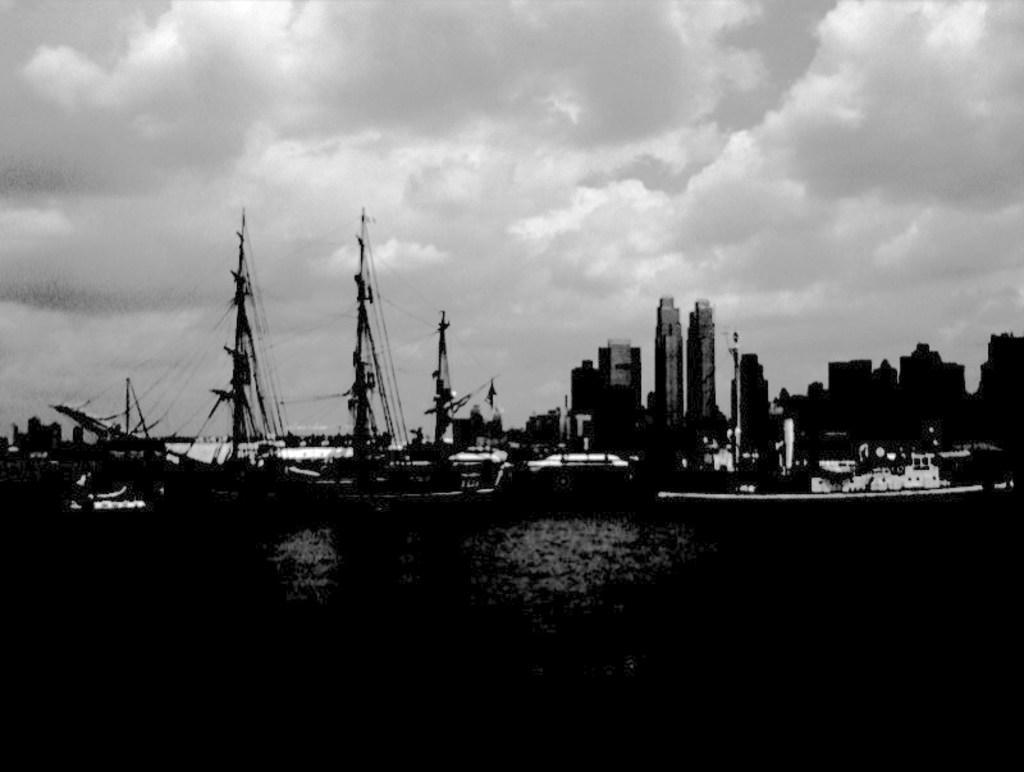In one or two sentences, can you explain what this image depicts? This is a black and white image. In the image there are many boats with poles and ropes. And also there are many buildings. At the top of the image there is sky with clouds. 